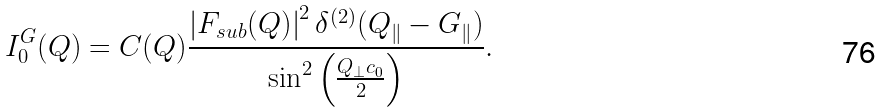Convert formula to latex. <formula><loc_0><loc_0><loc_500><loc_500>I _ { 0 } ^ { G } ( Q ) = C ( Q ) \frac { \left | F _ { s u b } ( Q ) \right | ^ { 2 } \delta ^ { ( 2 ) } ( Q _ { \| } - G _ { \| } ) } { \sin ^ { 2 } \left ( \frac { Q _ { \perp } c _ { 0 } } { 2 } \right ) } .</formula> 